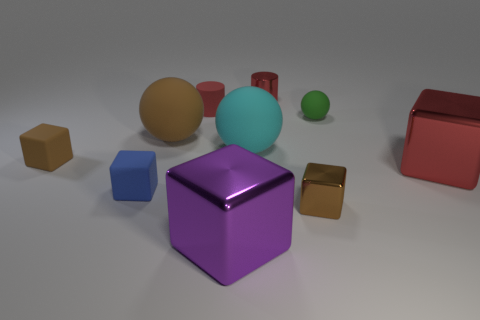There is a brown sphere that is the same material as the big cyan sphere; what is its size?
Give a very brief answer. Large. What shape is the big thing that is the same color as the metal cylinder?
Offer a terse response. Cube. There is a tiny metal thing behind the small brown rubber thing; is it the same color as the large metallic block that is on the right side of the small green object?
Keep it short and to the point. Yes. Is there a thing of the same color as the small metal cylinder?
Ensure brevity in your answer.  Yes. Do the red metallic thing that is behind the green rubber thing and the tiny rubber sphere have the same size?
Give a very brief answer. Yes. Are there the same number of large red blocks behind the tiny green thing and small gray rubber spheres?
Provide a succinct answer. Yes. How many objects are either tiny cubes behind the tiny blue thing or cylinders?
Offer a very short reply. 3. There is a small rubber object that is both to the left of the green thing and behind the brown matte cube; what shape is it?
Ensure brevity in your answer.  Cylinder. What number of things are either cylinders left of the tiny red shiny cylinder or things that are on the left side of the red rubber cylinder?
Your response must be concise. 4. What number of other things are there of the same size as the brown metallic object?
Offer a terse response. 5. 